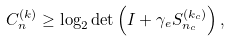<formula> <loc_0><loc_0><loc_500><loc_500>C _ { n } ^ { ( k ) } \geq { \log } _ { 2 } \det \left ( I + \gamma _ { e } S _ { n _ { c } } ^ { ( k _ { c } ) } \right ) ,</formula> 